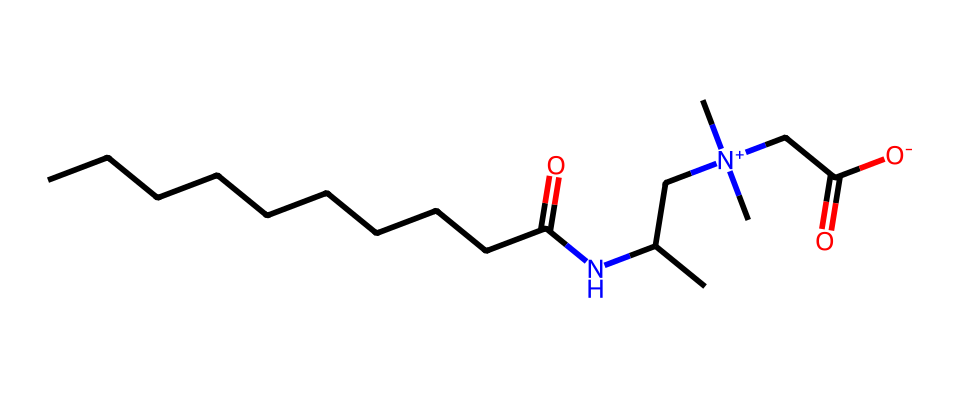What is the name of this chemical? The SMILES representation provided corresponds to Cocamidopropyl betaine. This is a well-known surfactant and is commonly found in personal care products.
Answer: Cocamidopropyl betaine How many carbon atoms are in the structure? Counting the carbon atoms in the SMILES, we can identify there are 14 carbon atoms present in total, including those in the chain and the functional groups.
Answer: 14 What type of functional group is present in Cocamidopropyl betaine? The functional groups seen in the structure include an amide (-C(=O)N-) and a carboxylate (-C(=O)[O-]). These determine the behavior of the molecule in surfactant applications.
Answer: Amide and carboxylate How many nitrogen atoms are present in the structure? Reviewing the SMILES for nitrogen atoms, we see there are 2 nitrogen atoms present in the chemical structure, indicated by ‘N’ symbols.
Answer: 2 What charge does the quaternary nitrogen carry? The nitrogen atom connected to four carbon atoms has a positive charge shown with "[N+]", which indicates that it is quaternary and positively charged, making it a cation.
Answer: Positive What is the role of Cocamidopropyl betaine in personal care products? Cocamidopropyl betaine primarily functions as a mild surfactant, which helps in cleansing and foaming properties, making it suitable for various personal care products.
Answer: Surfactant 